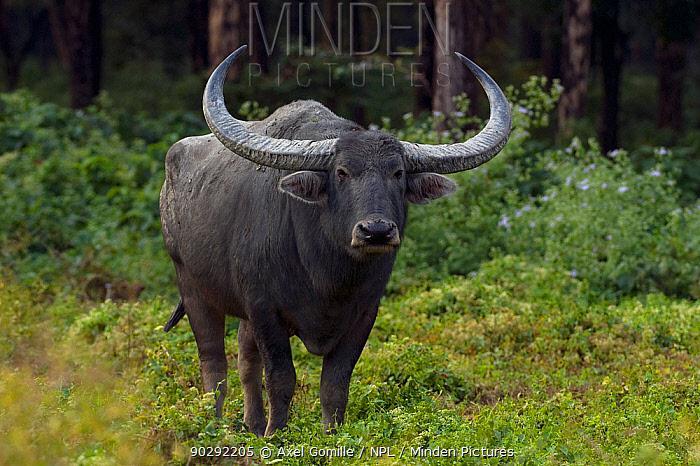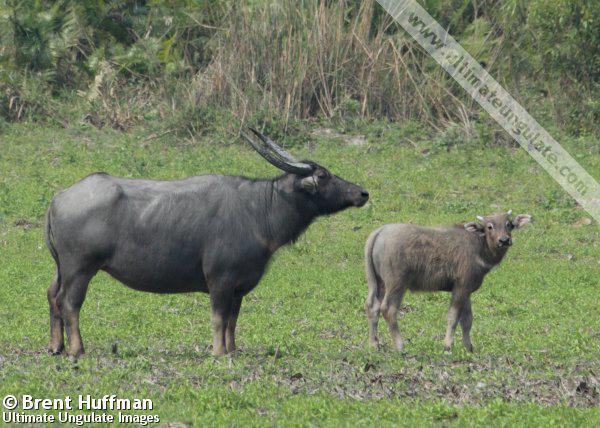The first image is the image on the left, the second image is the image on the right. Examine the images to the left and right. Is the description "Two animals are standing in the grass in one of the pictures." accurate? Answer yes or no. Yes. The first image is the image on the left, the second image is the image on the right. For the images displayed, is the sentence "There are 3 animals in the images" factually correct? Answer yes or no. Yes. 